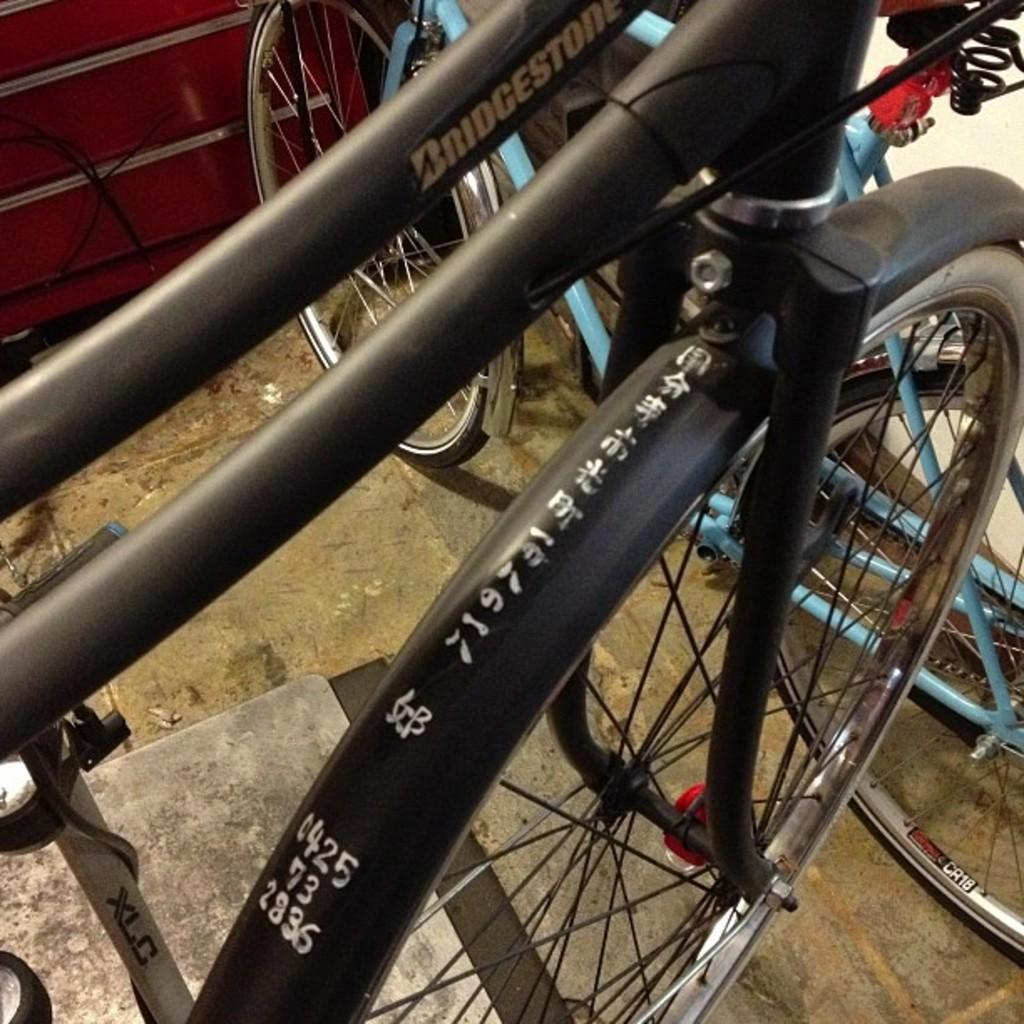What type of vehicles are in the image? There are bicycles present in the image. Where are the bicycles located? The bicycles are on the ground. What type of drink is being served in the image? There is no drink present in the image; it only features bicycles on the ground. Is there a bear interacting with the bicycles in the image? No, there is no bear present in the image. 